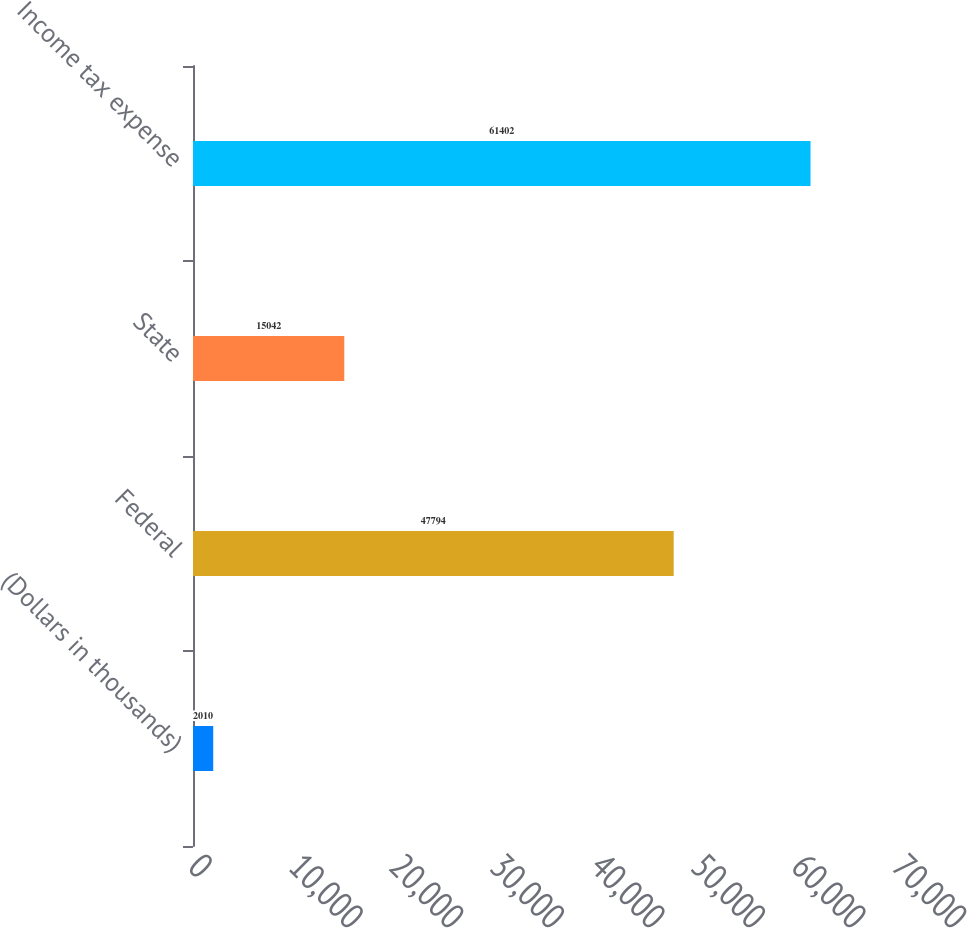<chart> <loc_0><loc_0><loc_500><loc_500><bar_chart><fcel>(Dollars in thousands)<fcel>Federal<fcel>State<fcel>Income tax expense<nl><fcel>2010<fcel>47794<fcel>15042<fcel>61402<nl></chart> 